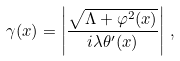<formula> <loc_0><loc_0><loc_500><loc_500>\gamma ( x ) = \left | \frac { \sqrt { \Lambda + \varphi ^ { 2 } ( x ) } } { i \lambda \theta ^ { \prime } ( x ) } \right | \, ,</formula> 